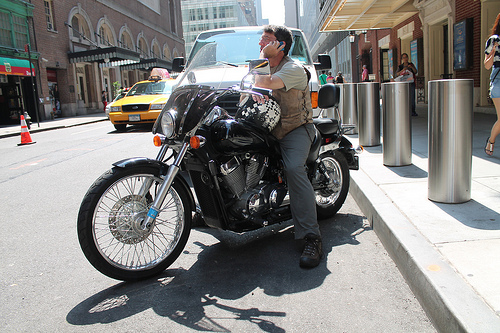How is the vehicle to the right of the cone called? The vehicle to the right of the cone is commonly called a taxi, and it is painted in the distinctive yellow color associated with taxis in many cities. 